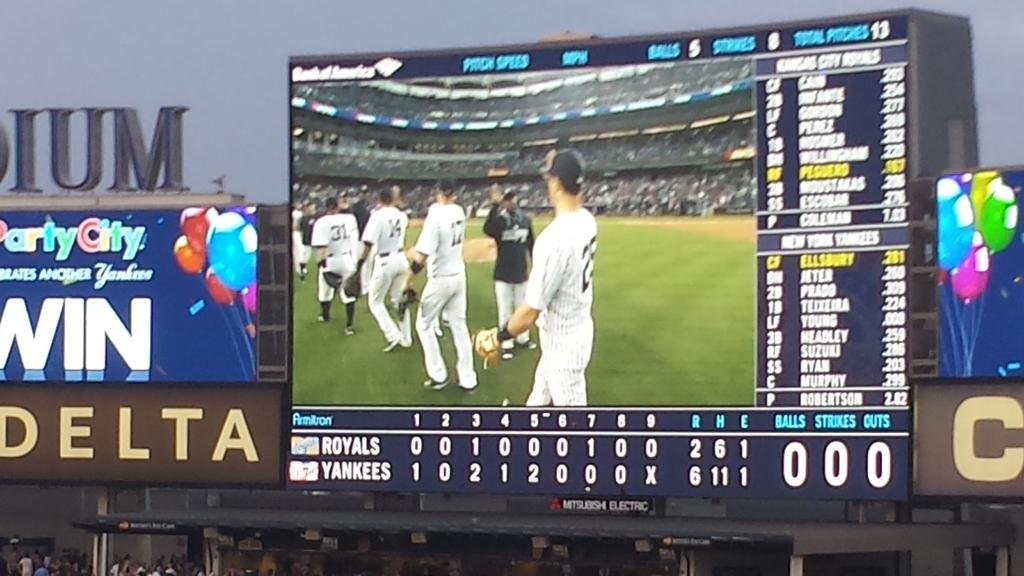<image>
Summarize the visual content of the image. a screen at a baseball game has a Delta sign to the left 